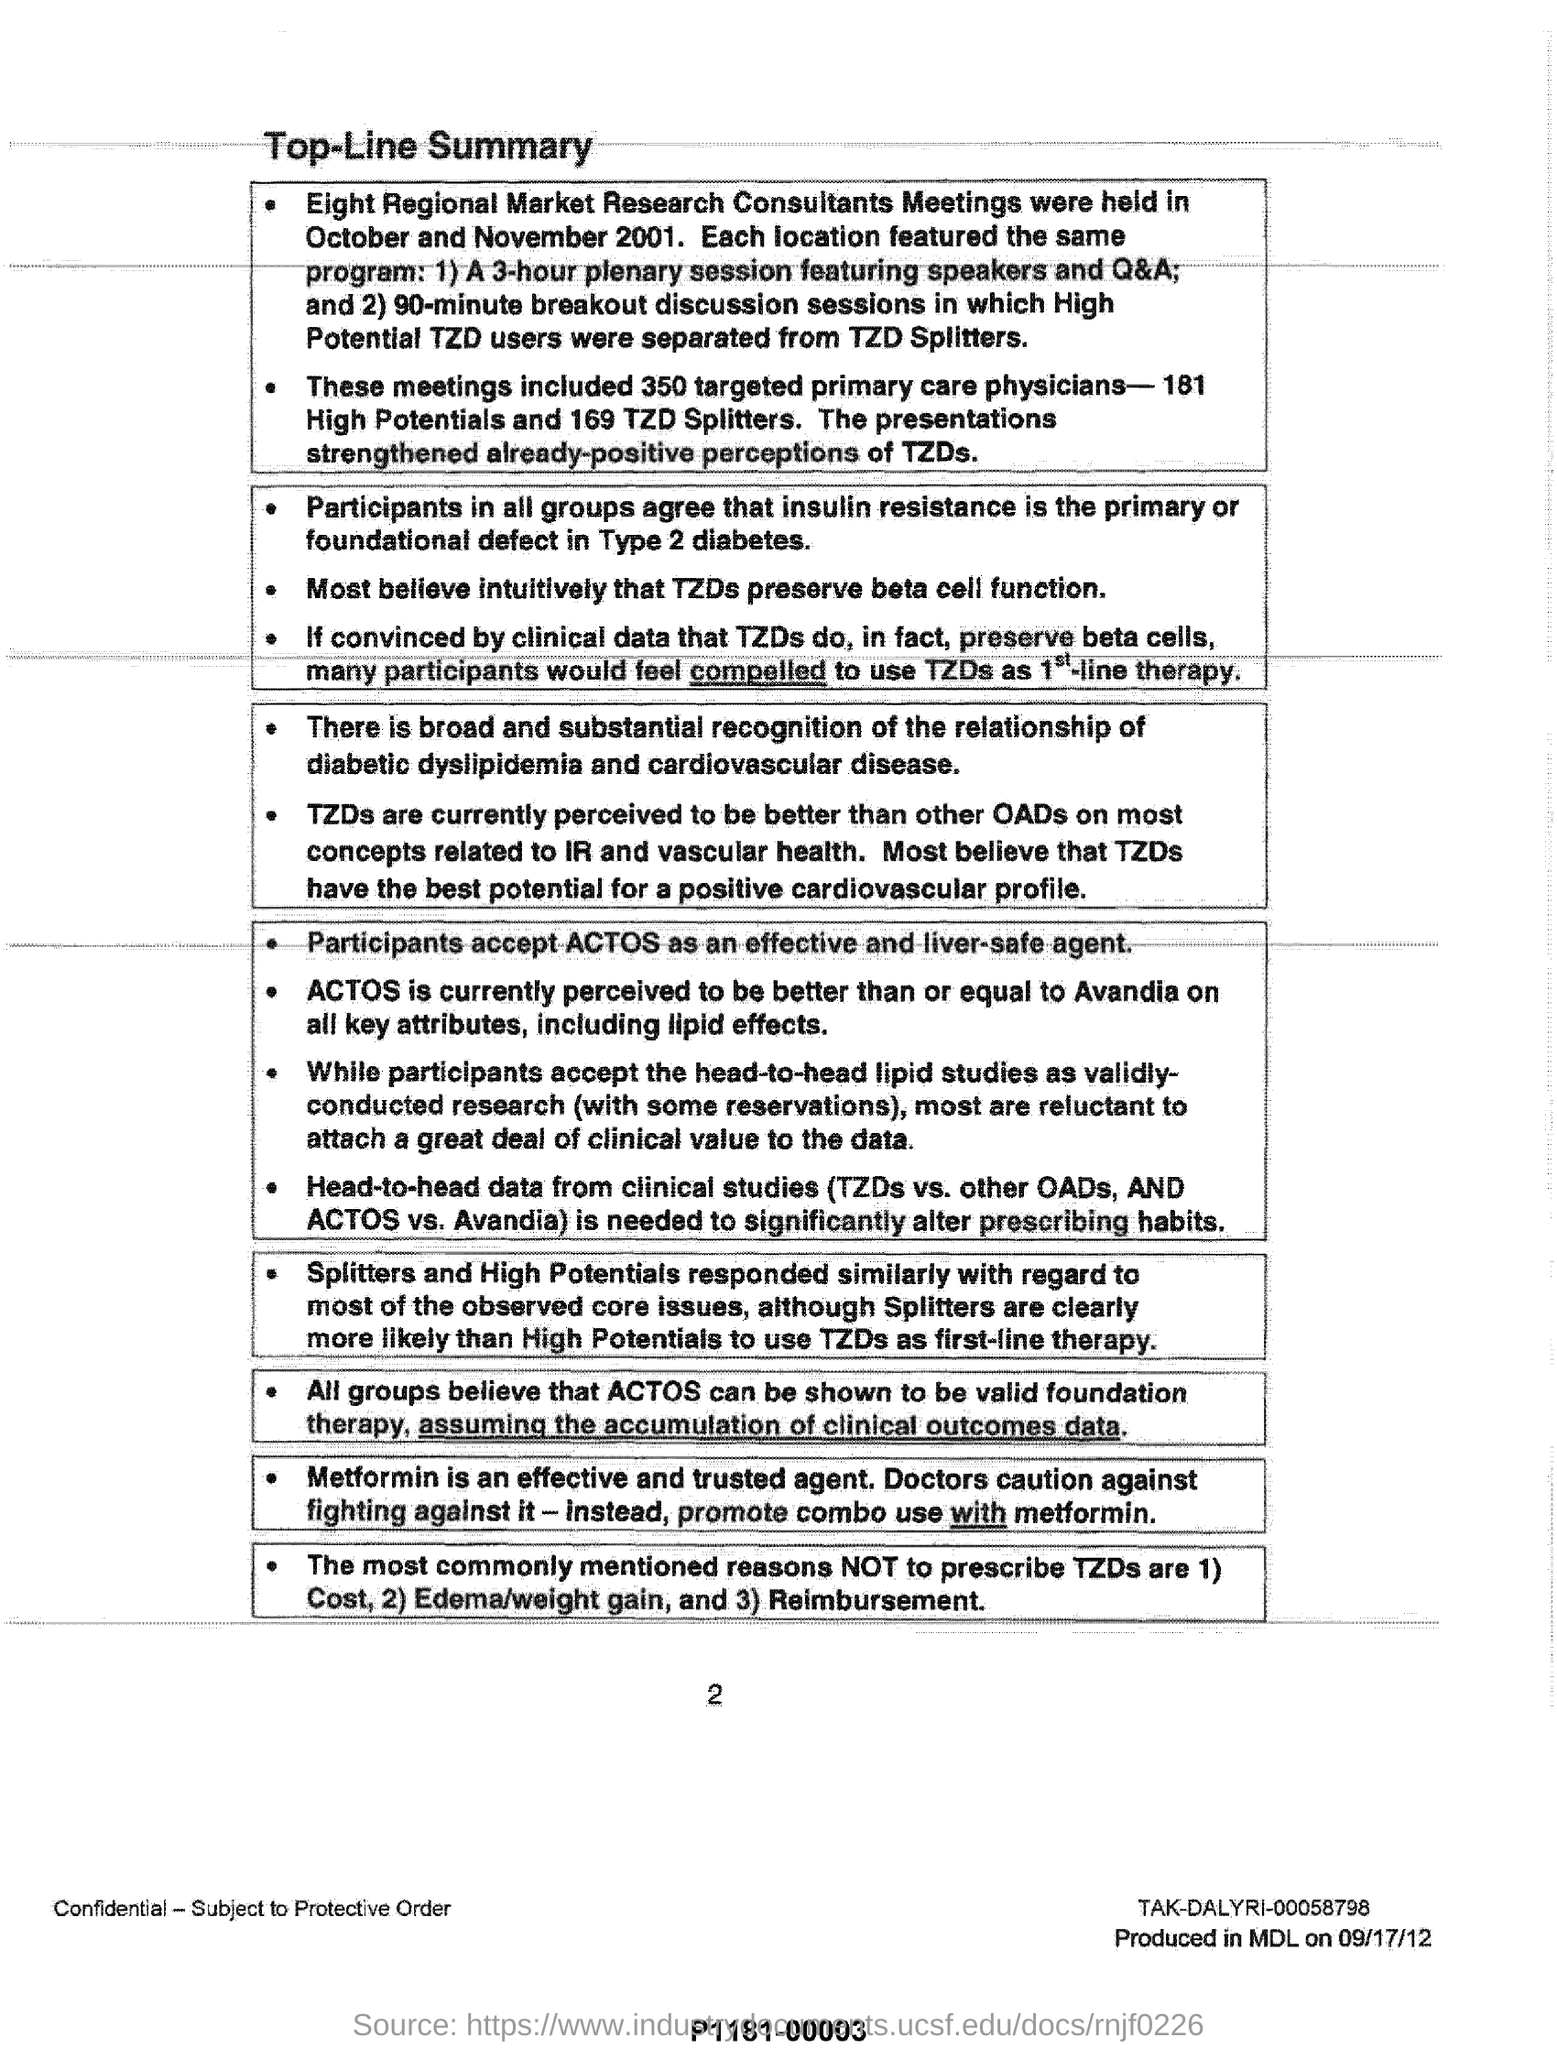Highlight a few significant elements in this photo. The most commonly mentioned reasons for not prescribing thiazide diuretics are cost, the risk of edema and weight gain, and reimbursement issues. Thirty-five targeted primary care physicians have been included in the meetings. Eight regional market research consultant meetings were held in October and November 2001. Metformin is an effective and trusted agent for the treatment of type 2 diabetes. ACTOS is an effective and safe liver agent that is accepted by participants. 